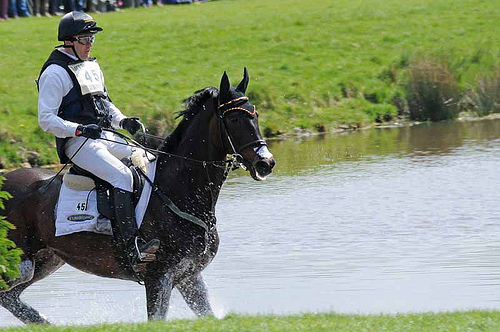Are the trousers white or black? The trousers in the picture are white. 